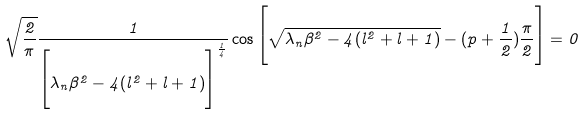<formula> <loc_0><loc_0><loc_500><loc_500>\sqrt { \frac { 2 } { \pi } } \frac { 1 } { \Big { [ } \lambda _ { n } \beta ^ { 2 } - 4 ( l ^ { 2 } + l + 1 ) \Big { ] } ^ { \frac { 1 } { 4 } } } \cos \Big { [ } \sqrt { \lambda _ { n } \beta ^ { 2 } - 4 ( l ^ { 2 } + l + 1 ) } - ( p + \frac { 1 } { 2 } ) \frac { \pi } { 2 } \Big { ] } = 0</formula> 